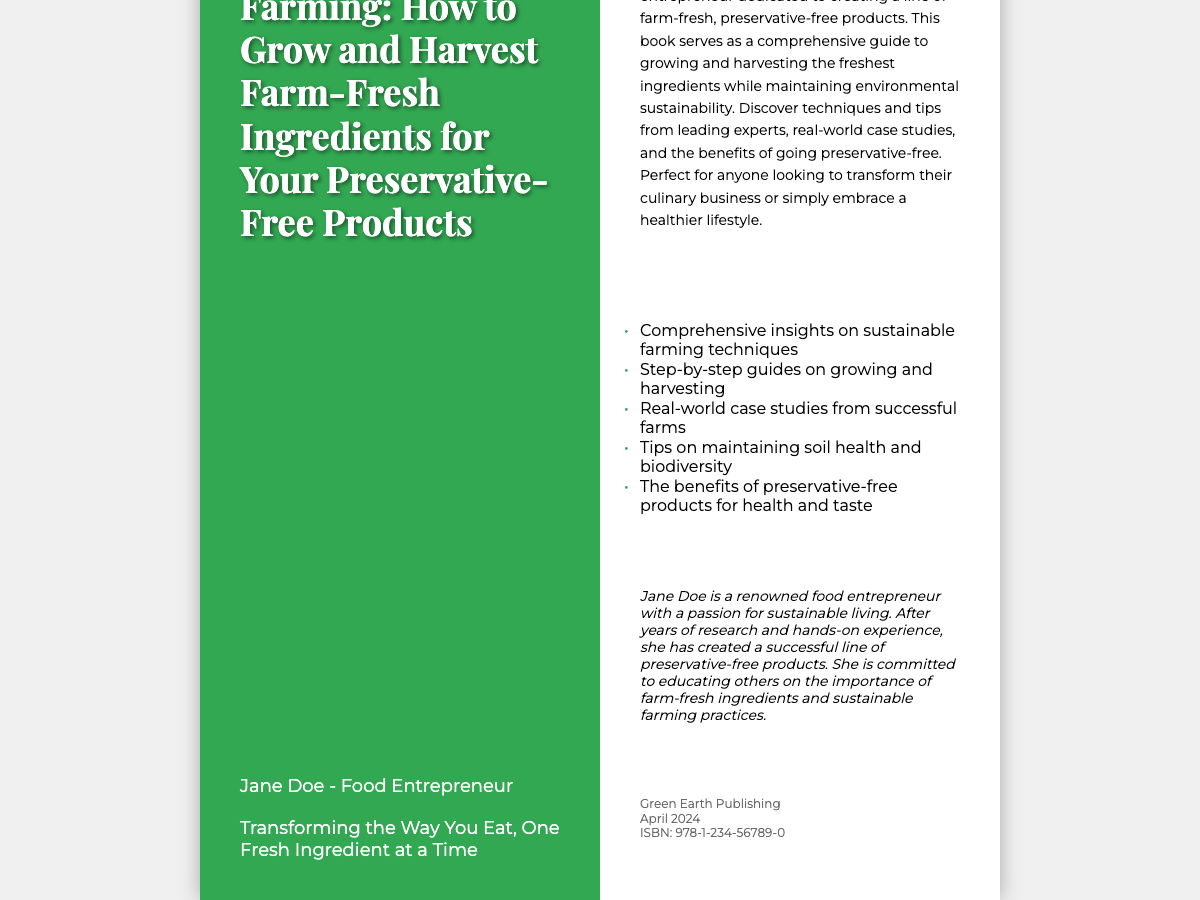what is the title of the book? The title of the book is clearly stated on the front cover as "Sustainable Farming: How to Grow and Harvest Farm-Fresh Ingredients for Your Preservative-Free Products."
Answer: Sustainable Farming: How to Grow and Harvest Farm-Fresh Ingredients for Your Preservative-Free Products who is the author of the book? The author's name is mentioned under the title on the front cover, which is Jane Doe.
Answer: Jane Doe what is the tagline of the book? The tagline is located under the author's name, which is "Transforming the Way You Eat, One Fresh Ingredient at a Time."
Answer: Transforming the Way You Eat, One Fresh Ingredient at a Time what type of publishing company is Green Earth Publishing? The publisher's name including "Green Earth Publishing" is found in the publisher info section on the back cover.
Answer: Green Earth Publishing when will the book be published? The publication month and year are specified in the publisher info section, which is "April 2024."
Answer: April 2024 how many bullet points are listed in the summary? The number of bullet points is obtained from the back cover where five bullet points are provided.
Answer: 5 what is the main focus of the book? The summary section details the book's focus, which is on sustainable farming and creating preservative-free products.
Answer: Sustainable farming and creating preservative-free products who is the targeted audience for this book? The summary indicates that the book is perfect for anyone looking to transform their culinary business or embrace a healthier lifestyle.
Answer: Culinary business or healthier lifestyle 